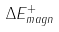<formula> <loc_0><loc_0><loc_500><loc_500>\Delta E ^ { + } _ { m a g n }</formula> 